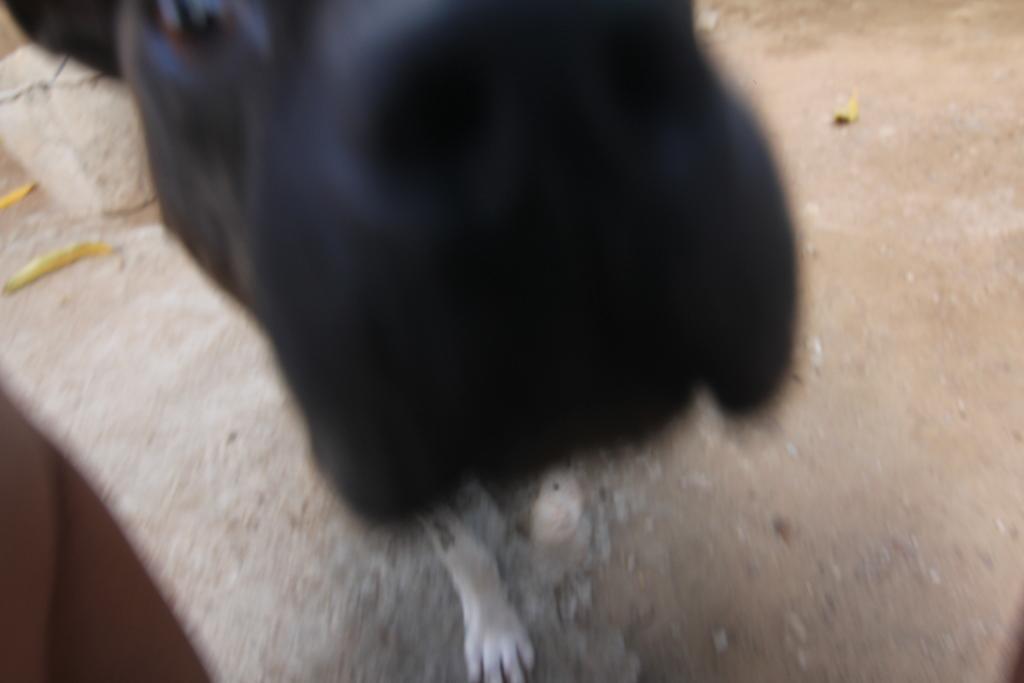Could you give a brief overview of what you see in this image? In this image we can see a dog standing on the ground. 